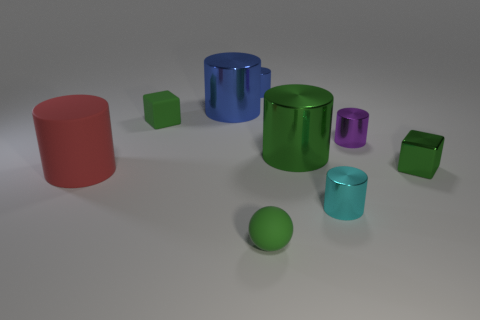Do the large red cylinder that is to the left of the small cyan metallic thing and the sphere have the same material?
Your answer should be compact. Yes. What number of things are big cylinders or tiny green things?
Give a very brief answer. 6. What is the size of the purple object that is the same shape as the small blue metal object?
Your answer should be compact. Small. How big is the green shiny block?
Make the answer very short. Small. Is the number of purple metallic objects that are right of the metal block greater than the number of tiny yellow matte blocks?
Keep it short and to the point. No. There is a shiny cylinder that is in front of the red matte cylinder; is its color the same as the rubber thing that is behind the big red rubber thing?
Offer a terse response. No. What material is the small green cube left of the tiny shiny thing behind the small green cube left of the big blue shiny cylinder made of?
Provide a short and direct response. Rubber. Are there more tiny cyan metal things than small matte objects?
Keep it short and to the point. No. Is there any other thing that is the same color as the big matte thing?
Provide a succinct answer. No. There is a ball that is the same material as the large red cylinder; what is its size?
Keep it short and to the point. Small. 